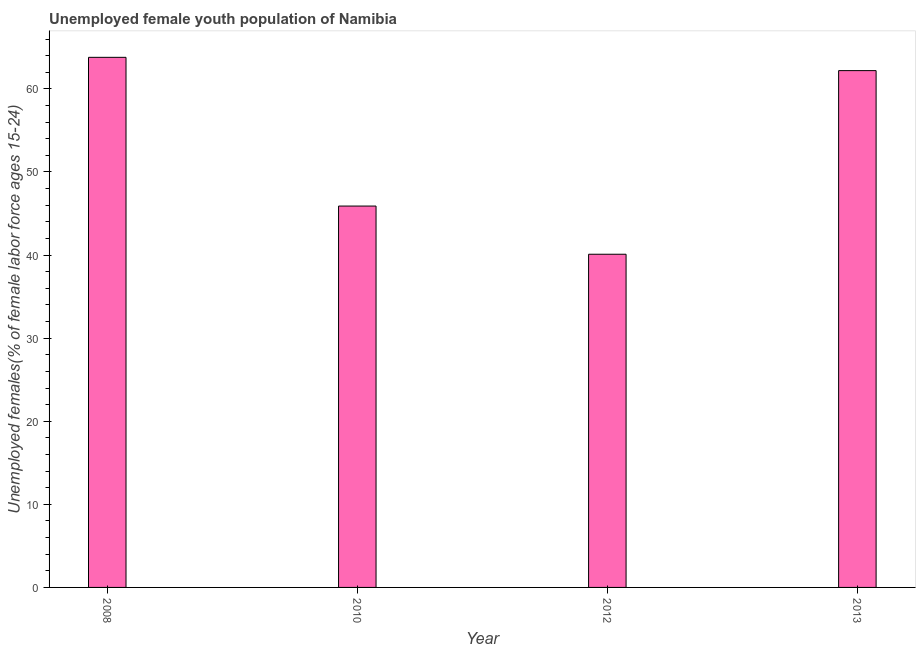What is the title of the graph?
Give a very brief answer. Unemployed female youth population of Namibia. What is the label or title of the X-axis?
Keep it short and to the point. Year. What is the label or title of the Y-axis?
Offer a terse response. Unemployed females(% of female labor force ages 15-24). What is the unemployed female youth in 2012?
Ensure brevity in your answer.  40.1. Across all years, what is the maximum unemployed female youth?
Ensure brevity in your answer.  63.8. Across all years, what is the minimum unemployed female youth?
Provide a short and direct response. 40.1. In which year was the unemployed female youth maximum?
Provide a succinct answer. 2008. What is the sum of the unemployed female youth?
Give a very brief answer. 212. What is the difference between the unemployed female youth in 2012 and 2013?
Make the answer very short. -22.1. What is the average unemployed female youth per year?
Provide a succinct answer. 53. What is the median unemployed female youth?
Your answer should be very brief. 54.05. In how many years, is the unemployed female youth greater than 60 %?
Provide a short and direct response. 2. Do a majority of the years between 2010 and 2012 (inclusive) have unemployed female youth greater than 2 %?
Ensure brevity in your answer.  Yes. What is the ratio of the unemployed female youth in 2012 to that in 2013?
Make the answer very short. 0.65. Is the unemployed female youth in 2010 less than that in 2013?
Your answer should be compact. Yes. What is the difference between the highest and the second highest unemployed female youth?
Make the answer very short. 1.6. Is the sum of the unemployed female youth in 2010 and 2012 greater than the maximum unemployed female youth across all years?
Provide a succinct answer. Yes. What is the difference between the highest and the lowest unemployed female youth?
Your answer should be compact. 23.7. In how many years, is the unemployed female youth greater than the average unemployed female youth taken over all years?
Offer a very short reply. 2. How many years are there in the graph?
Keep it short and to the point. 4. What is the difference between two consecutive major ticks on the Y-axis?
Make the answer very short. 10. What is the Unemployed females(% of female labor force ages 15-24) in 2008?
Keep it short and to the point. 63.8. What is the Unemployed females(% of female labor force ages 15-24) of 2010?
Provide a short and direct response. 45.9. What is the Unemployed females(% of female labor force ages 15-24) of 2012?
Your answer should be compact. 40.1. What is the Unemployed females(% of female labor force ages 15-24) of 2013?
Provide a succinct answer. 62.2. What is the difference between the Unemployed females(% of female labor force ages 15-24) in 2008 and 2012?
Ensure brevity in your answer.  23.7. What is the difference between the Unemployed females(% of female labor force ages 15-24) in 2010 and 2012?
Offer a very short reply. 5.8. What is the difference between the Unemployed females(% of female labor force ages 15-24) in 2010 and 2013?
Your answer should be very brief. -16.3. What is the difference between the Unemployed females(% of female labor force ages 15-24) in 2012 and 2013?
Offer a very short reply. -22.1. What is the ratio of the Unemployed females(% of female labor force ages 15-24) in 2008 to that in 2010?
Your answer should be compact. 1.39. What is the ratio of the Unemployed females(% of female labor force ages 15-24) in 2008 to that in 2012?
Offer a terse response. 1.59. What is the ratio of the Unemployed females(% of female labor force ages 15-24) in 2010 to that in 2012?
Your answer should be compact. 1.15. What is the ratio of the Unemployed females(% of female labor force ages 15-24) in 2010 to that in 2013?
Your answer should be very brief. 0.74. What is the ratio of the Unemployed females(% of female labor force ages 15-24) in 2012 to that in 2013?
Offer a terse response. 0.65. 